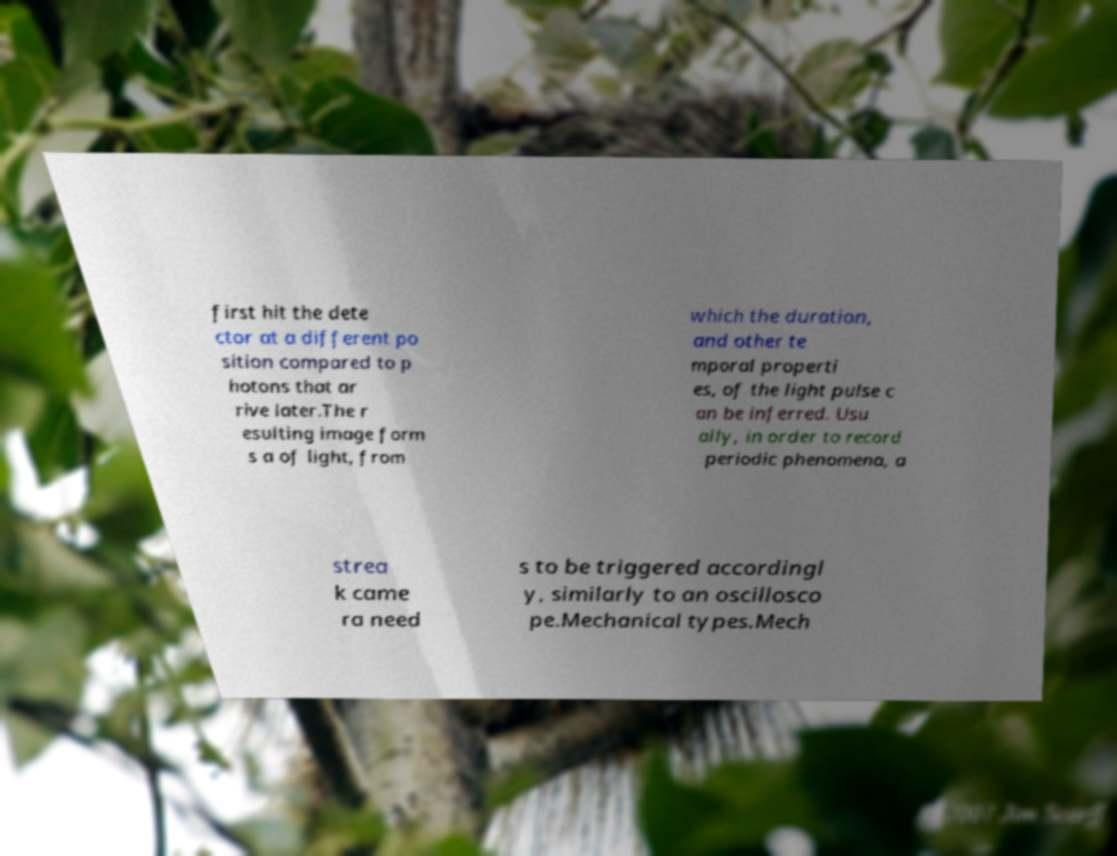Can you read and provide the text displayed in the image?This photo seems to have some interesting text. Can you extract and type it out for me? first hit the dete ctor at a different po sition compared to p hotons that ar rive later.The r esulting image form s a of light, from which the duration, and other te mporal properti es, of the light pulse c an be inferred. Usu ally, in order to record periodic phenomena, a strea k came ra need s to be triggered accordingl y, similarly to an oscillosco pe.Mechanical types.Mech 